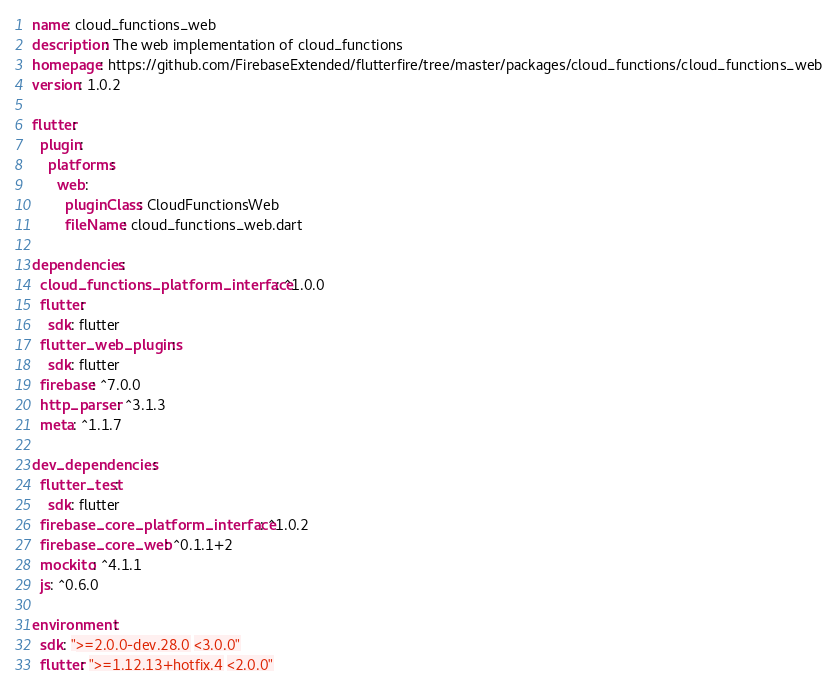Convert code to text. <code><loc_0><loc_0><loc_500><loc_500><_YAML_>name: cloud_functions_web
description: The web implementation of cloud_functions
homepage: https://github.com/FirebaseExtended/flutterfire/tree/master/packages/cloud_functions/cloud_functions_web
version: 1.0.2

flutter:
  plugin:
    platforms:
      web:
        pluginClass: CloudFunctionsWeb
        fileName: cloud_functions_web.dart

dependencies:
  cloud_functions_platform_interface: ^1.0.0
  flutter:
    sdk: flutter
  flutter_web_plugins:
    sdk: flutter
  firebase: ^7.0.0
  http_parser: ^3.1.3
  meta: ^1.1.7

dev_dependencies:
  flutter_test:
    sdk: flutter
  firebase_core_platform_interface: ^1.0.2
  firebase_core_web: ^0.1.1+2
  mockito: ^4.1.1
  js: ^0.6.0

environment:
  sdk: ">=2.0.0-dev.28.0 <3.0.0"
  flutter: ">=1.12.13+hotfix.4 <2.0.0"

</code> 